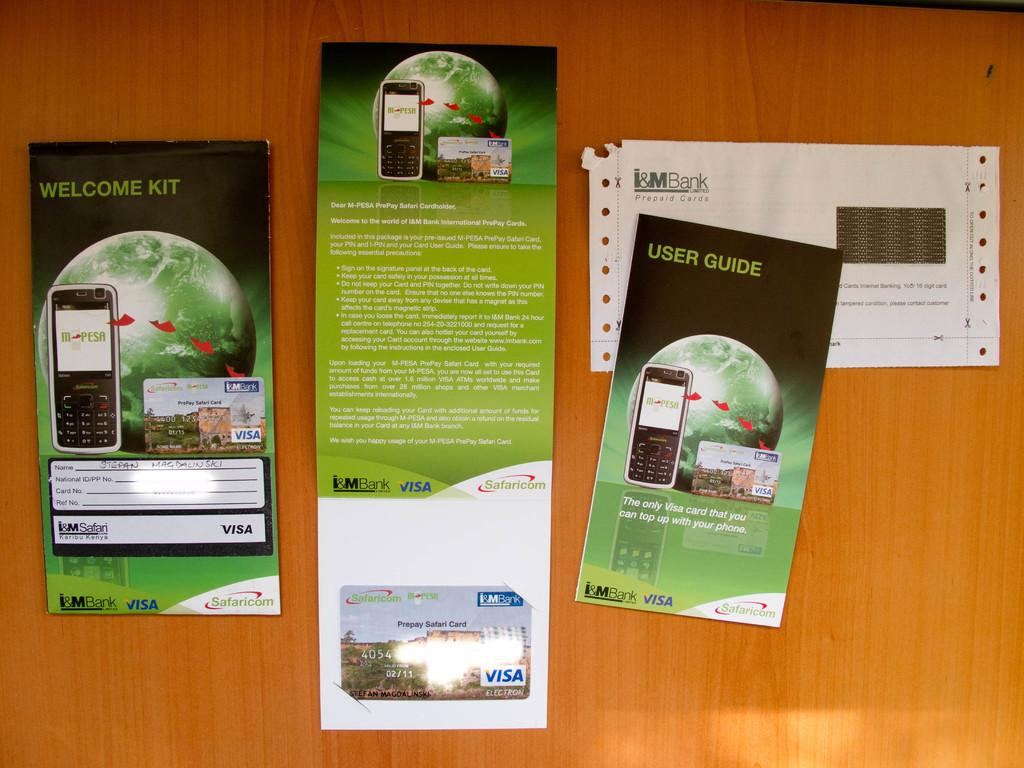<image>
Provide a brief description of the given image. The welcome package and VISA card are from I&M Bank. 